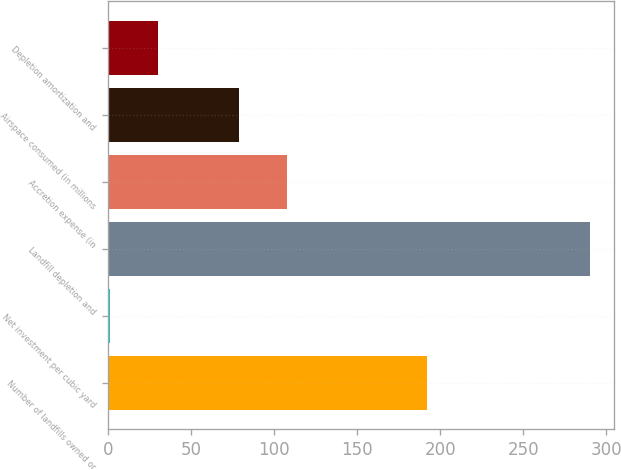<chart> <loc_0><loc_0><loc_500><loc_500><bar_chart><fcel>Number of landfills owned or<fcel>Net investment per cubic yard<fcel>Landfill depletion and<fcel>Accretion expense (in<fcel>Airspace consumed (in millions<fcel>Depletion amortization and<nl><fcel>192<fcel>0.72<fcel>290.2<fcel>107.85<fcel>78.9<fcel>29.67<nl></chart> 